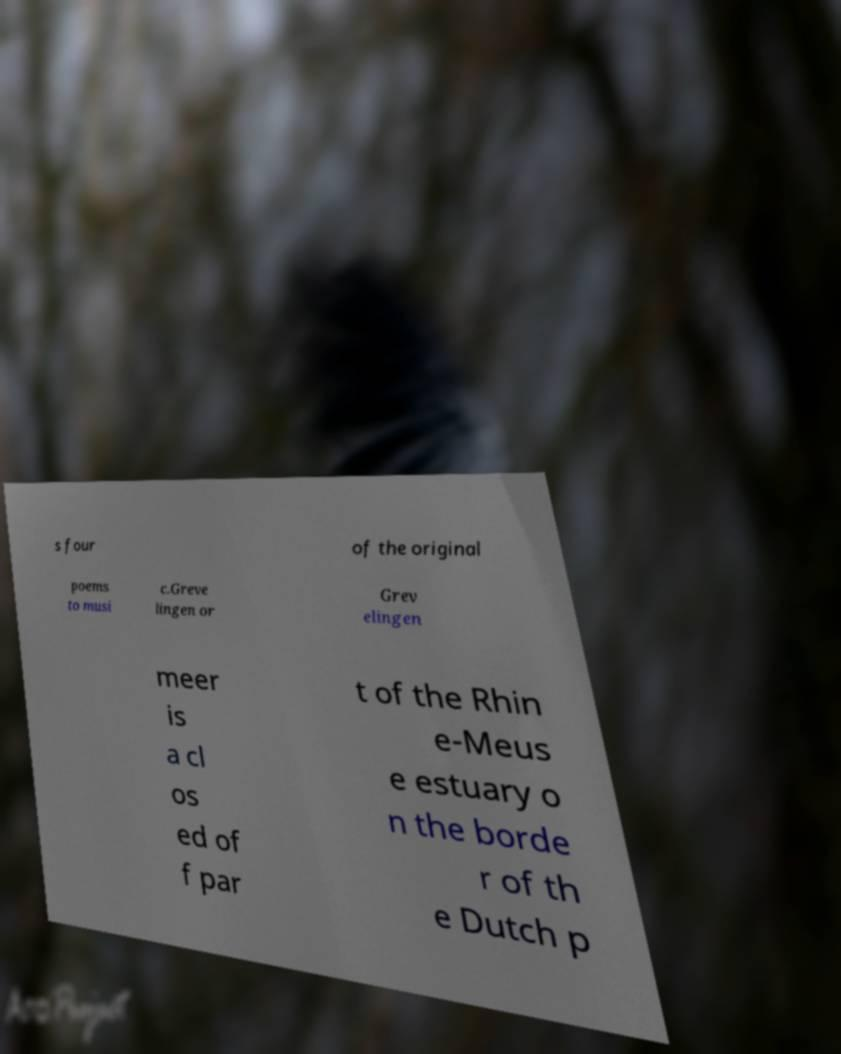Can you read and provide the text displayed in the image?This photo seems to have some interesting text. Can you extract and type it out for me? s four of the original poems to musi c.Greve lingen or Grev elingen meer is a cl os ed of f par t of the Rhin e-Meus e estuary o n the borde r of th e Dutch p 